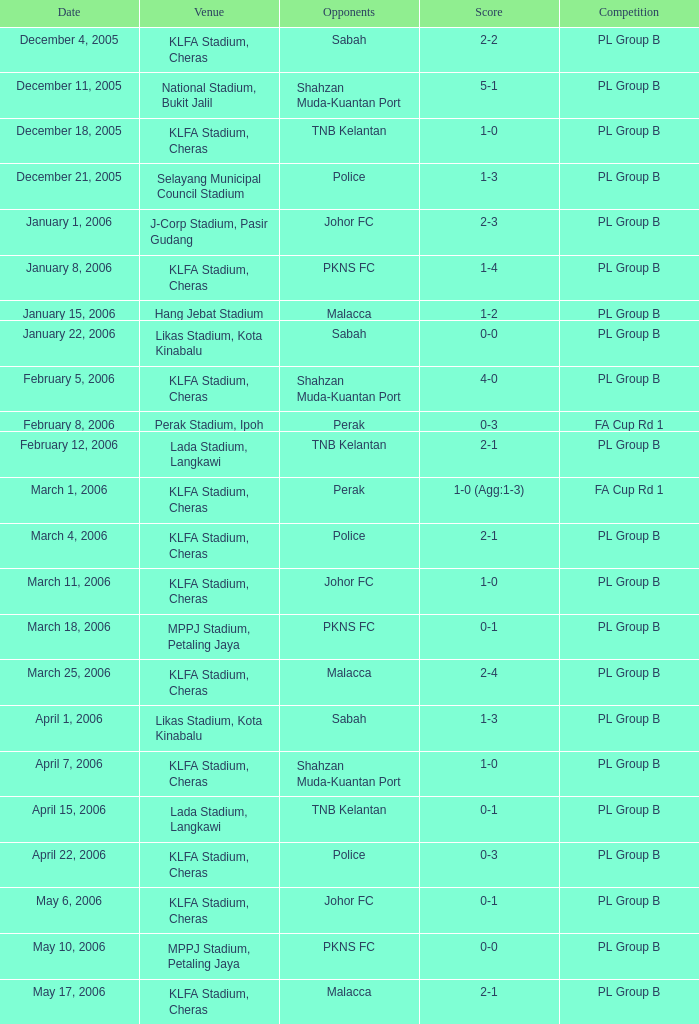Which location features a contest of pl group b, and has a result of 2-2? KLFA Stadium, Cheras. 